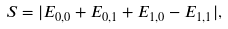Convert formula to latex. <formula><loc_0><loc_0><loc_500><loc_500>S = | E _ { 0 , 0 } + E _ { 0 , 1 } + E _ { 1 , 0 } - E _ { 1 , 1 } | ,</formula> 